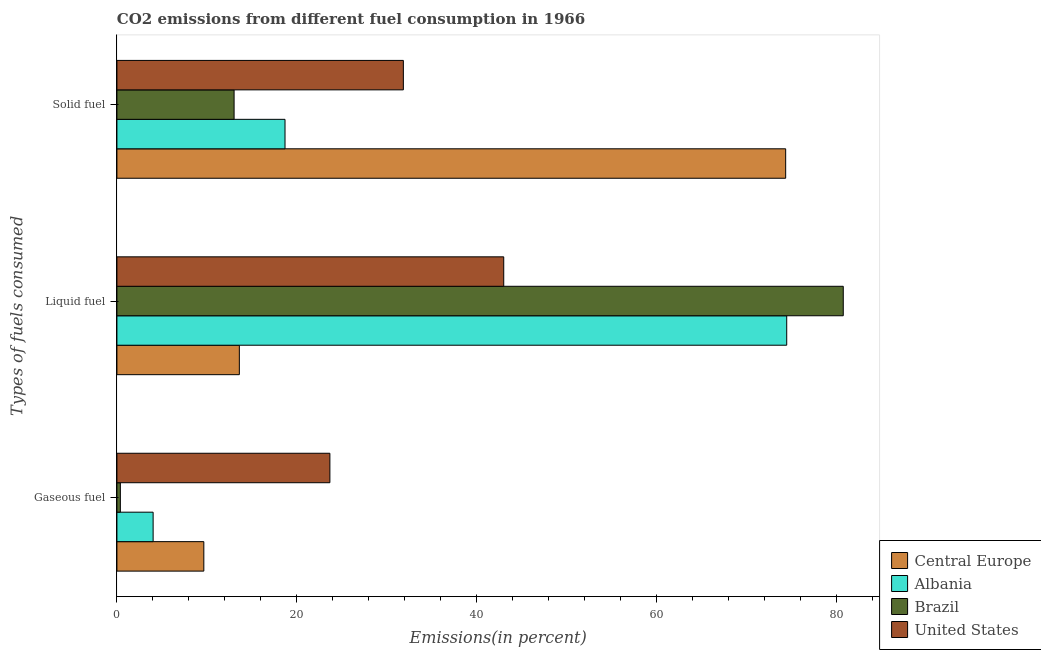How many different coloured bars are there?
Provide a succinct answer. 4. How many groups of bars are there?
Your answer should be very brief. 3. Are the number of bars on each tick of the Y-axis equal?
Keep it short and to the point. Yes. How many bars are there on the 2nd tick from the top?
Your answer should be compact. 4. How many bars are there on the 3rd tick from the bottom?
Ensure brevity in your answer.  4. What is the label of the 2nd group of bars from the top?
Provide a short and direct response. Liquid fuel. What is the percentage of solid fuel emission in Brazil?
Your response must be concise. 13.02. Across all countries, what is the maximum percentage of liquid fuel emission?
Your answer should be very brief. 80.71. Across all countries, what is the minimum percentage of liquid fuel emission?
Offer a terse response. 13.6. In which country was the percentage of solid fuel emission maximum?
Provide a succinct answer. Central Europe. What is the total percentage of solid fuel emission in the graph?
Provide a short and direct response. 137.83. What is the difference between the percentage of solid fuel emission in Albania and that in Central Europe?
Offer a very short reply. -55.63. What is the difference between the percentage of gaseous fuel emission in United States and the percentage of solid fuel emission in Central Europe?
Your answer should be compact. -50.64. What is the average percentage of solid fuel emission per country?
Provide a succinct answer. 34.46. What is the difference between the percentage of liquid fuel emission and percentage of solid fuel emission in Brazil?
Provide a succinct answer. 67.69. What is the ratio of the percentage of solid fuel emission in Central Europe to that in Brazil?
Make the answer very short. 5.71. What is the difference between the highest and the second highest percentage of liquid fuel emission?
Offer a very short reply. 6.28. What is the difference between the highest and the lowest percentage of liquid fuel emission?
Your answer should be compact. 67.1. In how many countries, is the percentage of liquid fuel emission greater than the average percentage of liquid fuel emission taken over all countries?
Give a very brief answer. 2. What does the 2nd bar from the top in Solid fuel represents?
Keep it short and to the point. Brazil. What does the 4th bar from the bottom in Liquid fuel represents?
Ensure brevity in your answer.  United States. Are all the bars in the graph horizontal?
Ensure brevity in your answer.  Yes. How many countries are there in the graph?
Your answer should be compact. 4. How are the legend labels stacked?
Ensure brevity in your answer.  Vertical. What is the title of the graph?
Your response must be concise. CO2 emissions from different fuel consumption in 1966. What is the label or title of the X-axis?
Make the answer very short. Emissions(in percent). What is the label or title of the Y-axis?
Make the answer very short. Types of fuels consumed. What is the Emissions(in percent) of Central Europe in Gaseous fuel?
Make the answer very short. 9.66. What is the Emissions(in percent) of Albania in Gaseous fuel?
Your answer should be compact. 4.02. What is the Emissions(in percent) of Brazil in Gaseous fuel?
Your answer should be compact. 0.38. What is the Emissions(in percent) in United States in Gaseous fuel?
Your answer should be very brief. 23.66. What is the Emissions(in percent) of Central Europe in Liquid fuel?
Provide a succinct answer. 13.6. What is the Emissions(in percent) of Albania in Liquid fuel?
Offer a terse response. 74.43. What is the Emissions(in percent) of Brazil in Liquid fuel?
Offer a terse response. 80.71. What is the Emissions(in percent) of United States in Liquid fuel?
Give a very brief answer. 42.98. What is the Emissions(in percent) in Central Europe in Solid fuel?
Your answer should be compact. 74.31. What is the Emissions(in percent) of Albania in Solid fuel?
Your answer should be compact. 18.68. What is the Emissions(in percent) in Brazil in Solid fuel?
Provide a succinct answer. 13.02. What is the Emissions(in percent) of United States in Solid fuel?
Make the answer very short. 31.83. Across all Types of fuels consumed, what is the maximum Emissions(in percent) in Central Europe?
Make the answer very short. 74.31. Across all Types of fuels consumed, what is the maximum Emissions(in percent) of Albania?
Give a very brief answer. 74.43. Across all Types of fuels consumed, what is the maximum Emissions(in percent) in Brazil?
Keep it short and to the point. 80.71. Across all Types of fuels consumed, what is the maximum Emissions(in percent) of United States?
Give a very brief answer. 42.98. Across all Types of fuels consumed, what is the minimum Emissions(in percent) in Central Europe?
Provide a succinct answer. 9.66. Across all Types of fuels consumed, what is the minimum Emissions(in percent) of Albania?
Provide a short and direct response. 4.02. Across all Types of fuels consumed, what is the minimum Emissions(in percent) in Brazil?
Ensure brevity in your answer.  0.38. Across all Types of fuels consumed, what is the minimum Emissions(in percent) of United States?
Provide a short and direct response. 23.66. What is the total Emissions(in percent) of Central Europe in the graph?
Provide a succinct answer. 97.57. What is the total Emissions(in percent) of Albania in the graph?
Offer a very short reply. 97.13. What is the total Emissions(in percent) of Brazil in the graph?
Give a very brief answer. 94.11. What is the total Emissions(in percent) of United States in the graph?
Ensure brevity in your answer.  98.47. What is the difference between the Emissions(in percent) of Central Europe in Gaseous fuel and that in Liquid fuel?
Provide a short and direct response. -3.95. What is the difference between the Emissions(in percent) of Albania in Gaseous fuel and that in Liquid fuel?
Your answer should be compact. -70.4. What is the difference between the Emissions(in percent) of Brazil in Gaseous fuel and that in Liquid fuel?
Your response must be concise. -80.33. What is the difference between the Emissions(in percent) in United States in Gaseous fuel and that in Liquid fuel?
Your response must be concise. -19.32. What is the difference between the Emissions(in percent) in Central Europe in Gaseous fuel and that in Solid fuel?
Your answer should be compact. -64.65. What is the difference between the Emissions(in percent) in Albania in Gaseous fuel and that in Solid fuel?
Keep it short and to the point. -14.66. What is the difference between the Emissions(in percent) of Brazil in Gaseous fuel and that in Solid fuel?
Give a very brief answer. -12.64. What is the difference between the Emissions(in percent) in United States in Gaseous fuel and that in Solid fuel?
Keep it short and to the point. -8.16. What is the difference between the Emissions(in percent) in Central Europe in Liquid fuel and that in Solid fuel?
Your answer should be very brief. -60.7. What is the difference between the Emissions(in percent) in Albania in Liquid fuel and that in Solid fuel?
Provide a succinct answer. 55.75. What is the difference between the Emissions(in percent) in Brazil in Liquid fuel and that in Solid fuel?
Give a very brief answer. 67.69. What is the difference between the Emissions(in percent) in United States in Liquid fuel and that in Solid fuel?
Provide a succinct answer. 11.15. What is the difference between the Emissions(in percent) in Central Europe in Gaseous fuel and the Emissions(in percent) in Albania in Liquid fuel?
Provide a short and direct response. -64.77. What is the difference between the Emissions(in percent) of Central Europe in Gaseous fuel and the Emissions(in percent) of Brazil in Liquid fuel?
Provide a short and direct response. -71.05. What is the difference between the Emissions(in percent) of Central Europe in Gaseous fuel and the Emissions(in percent) of United States in Liquid fuel?
Provide a succinct answer. -33.32. What is the difference between the Emissions(in percent) in Albania in Gaseous fuel and the Emissions(in percent) in Brazil in Liquid fuel?
Keep it short and to the point. -76.69. What is the difference between the Emissions(in percent) of Albania in Gaseous fuel and the Emissions(in percent) of United States in Liquid fuel?
Make the answer very short. -38.96. What is the difference between the Emissions(in percent) of Brazil in Gaseous fuel and the Emissions(in percent) of United States in Liquid fuel?
Your answer should be compact. -42.6. What is the difference between the Emissions(in percent) of Central Europe in Gaseous fuel and the Emissions(in percent) of Albania in Solid fuel?
Give a very brief answer. -9.02. What is the difference between the Emissions(in percent) of Central Europe in Gaseous fuel and the Emissions(in percent) of Brazil in Solid fuel?
Your answer should be compact. -3.36. What is the difference between the Emissions(in percent) of Central Europe in Gaseous fuel and the Emissions(in percent) of United States in Solid fuel?
Keep it short and to the point. -22.17. What is the difference between the Emissions(in percent) of Albania in Gaseous fuel and the Emissions(in percent) of Brazil in Solid fuel?
Offer a terse response. -9. What is the difference between the Emissions(in percent) in Albania in Gaseous fuel and the Emissions(in percent) in United States in Solid fuel?
Ensure brevity in your answer.  -27.8. What is the difference between the Emissions(in percent) of Brazil in Gaseous fuel and the Emissions(in percent) of United States in Solid fuel?
Your response must be concise. -31.45. What is the difference between the Emissions(in percent) of Central Europe in Liquid fuel and the Emissions(in percent) of Albania in Solid fuel?
Provide a succinct answer. -5.07. What is the difference between the Emissions(in percent) of Central Europe in Liquid fuel and the Emissions(in percent) of Brazil in Solid fuel?
Ensure brevity in your answer.  0.58. What is the difference between the Emissions(in percent) of Central Europe in Liquid fuel and the Emissions(in percent) of United States in Solid fuel?
Ensure brevity in your answer.  -18.22. What is the difference between the Emissions(in percent) in Albania in Liquid fuel and the Emissions(in percent) in Brazil in Solid fuel?
Offer a very short reply. 61.41. What is the difference between the Emissions(in percent) in Albania in Liquid fuel and the Emissions(in percent) in United States in Solid fuel?
Give a very brief answer. 42.6. What is the difference between the Emissions(in percent) of Brazil in Liquid fuel and the Emissions(in percent) of United States in Solid fuel?
Your answer should be very brief. 48.88. What is the average Emissions(in percent) in Central Europe per Types of fuels consumed?
Your answer should be compact. 32.52. What is the average Emissions(in percent) in Albania per Types of fuels consumed?
Make the answer very short. 32.38. What is the average Emissions(in percent) of Brazil per Types of fuels consumed?
Make the answer very short. 31.37. What is the average Emissions(in percent) of United States per Types of fuels consumed?
Provide a succinct answer. 32.82. What is the difference between the Emissions(in percent) in Central Europe and Emissions(in percent) in Albania in Gaseous fuel?
Your answer should be very brief. 5.63. What is the difference between the Emissions(in percent) in Central Europe and Emissions(in percent) in Brazil in Gaseous fuel?
Your answer should be very brief. 9.27. What is the difference between the Emissions(in percent) of Central Europe and Emissions(in percent) of United States in Gaseous fuel?
Provide a succinct answer. -14.01. What is the difference between the Emissions(in percent) in Albania and Emissions(in percent) in Brazil in Gaseous fuel?
Your response must be concise. 3.64. What is the difference between the Emissions(in percent) in Albania and Emissions(in percent) in United States in Gaseous fuel?
Offer a terse response. -19.64. What is the difference between the Emissions(in percent) of Brazil and Emissions(in percent) of United States in Gaseous fuel?
Offer a terse response. -23.28. What is the difference between the Emissions(in percent) of Central Europe and Emissions(in percent) of Albania in Liquid fuel?
Your answer should be very brief. -60.82. What is the difference between the Emissions(in percent) of Central Europe and Emissions(in percent) of Brazil in Liquid fuel?
Offer a very short reply. -67.1. What is the difference between the Emissions(in percent) of Central Europe and Emissions(in percent) of United States in Liquid fuel?
Make the answer very short. -29.38. What is the difference between the Emissions(in percent) in Albania and Emissions(in percent) in Brazil in Liquid fuel?
Give a very brief answer. -6.28. What is the difference between the Emissions(in percent) of Albania and Emissions(in percent) of United States in Liquid fuel?
Your response must be concise. 31.44. What is the difference between the Emissions(in percent) in Brazil and Emissions(in percent) in United States in Liquid fuel?
Provide a short and direct response. 37.73. What is the difference between the Emissions(in percent) in Central Europe and Emissions(in percent) in Albania in Solid fuel?
Provide a succinct answer. 55.63. What is the difference between the Emissions(in percent) of Central Europe and Emissions(in percent) of Brazil in Solid fuel?
Give a very brief answer. 61.29. What is the difference between the Emissions(in percent) in Central Europe and Emissions(in percent) in United States in Solid fuel?
Keep it short and to the point. 42.48. What is the difference between the Emissions(in percent) of Albania and Emissions(in percent) of Brazil in Solid fuel?
Your response must be concise. 5.66. What is the difference between the Emissions(in percent) in Albania and Emissions(in percent) in United States in Solid fuel?
Keep it short and to the point. -13.15. What is the difference between the Emissions(in percent) in Brazil and Emissions(in percent) in United States in Solid fuel?
Offer a very short reply. -18.81. What is the ratio of the Emissions(in percent) of Central Europe in Gaseous fuel to that in Liquid fuel?
Provide a short and direct response. 0.71. What is the ratio of the Emissions(in percent) of Albania in Gaseous fuel to that in Liquid fuel?
Ensure brevity in your answer.  0.05. What is the ratio of the Emissions(in percent) in Brazil in Gaseous fuel to that in Liquid fuel?
Offer a very short reply. 0. What is the ratio of the Emissions(in percent) of United States in Gaseous fuel to that in Liquid fuel?
Give a very brief answer. 0.55. What is the ratio of the Emissions(in percent) of Central Europe in Gaseous fuel to that in Solid fuel?
Keep it short and to the point. 0.13. What is the ratio of the Emissions(in percent) in Albania in Gaseous fuel to that in Solid fuel?
Your answer should be very brief. 0.22. What is the ratio of the Emissions(in percent) of Brazil in Gaseous fuel to that in Solid fuel?
Provide a short and direct response. 0.03. What is the ratio of the Emissions(in percent) of United States in Gaseous fuel to that in Solid fuel?
Provide a short and direct response. 0.74. What is the ratio of the Emissions(in percent) of Central Europe in Liquid fuel to that in Solid fuel?
Ensure brevity in your answer.  0.18. What is the ratio of the Emissions(in percent) of Albania in Liquid fuel to that in Solid fuel?
Your response must be concise. 3.98. What is the ratio of the Emissions(in percent) of Brazil in Liquid fuel to that in Solid fuel?
Offer a terse response. 6.2. What is the ratio of the Emissions(in percent) of United States in Liquid fuel to that in Solid fuel?
Provide a short and direct response. 1.35. What is the difference between the highest and the second highest Emissions(in percent) in Central Europe?
Offer a very short reply. 60.7. What is the difference between the highest and the second highest Emissions(in percent) in Albania?
Keep it short and to the point. 55.75. What is the difference between the highest and the second highest Emissions(in percent) in Brazil?
Your response must be concise. 67.69. What is the difference between the highest and the second highest Emissions(in percent) of United States?
Your answer should be very brief. 11.15. What is the difference between the highest and the lowest Emissions(in percent) in Central Europe?
Ensure brevity in your answer.  64.65. What is the difference between the highest and the lowest Emissions(in percent) of Albania?
Your response must be concise. 70.4. What is the difference between the highest and the lowest Emissions(in percent) of Brazil?
Your answer should be very brief. 80.33. What is the difference between the highest and the lowest Emissions(in percent) in United States?
Ensure brevity in your answer.  19.32. 